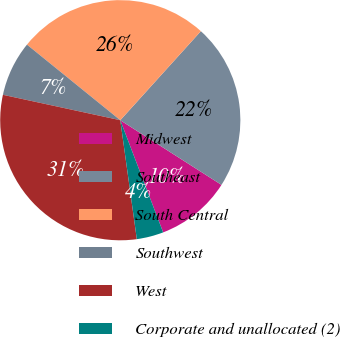Convert chart to OTSL. <chart><loc_0><loc_0><loc_500><loc_500><pie_chart><fcel>Midwest<fcel>Southeast<fcel>South Central<fcel>Southwest<fcel>West<fcel>Corporate and unallocated (2)<nl><fcel>10.14%<fcel>22.34%<fcel>25.87%<fcel>7.44%<fcel>30.59%<fcel>3.61%<nl></chart> 